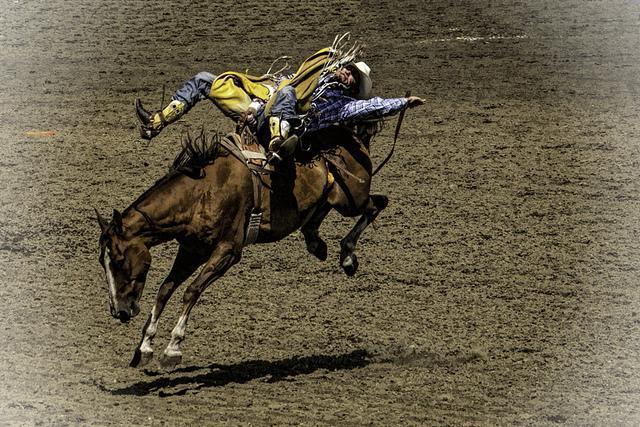How many zebras are in the photo?
Give a very brief answer. 0. 